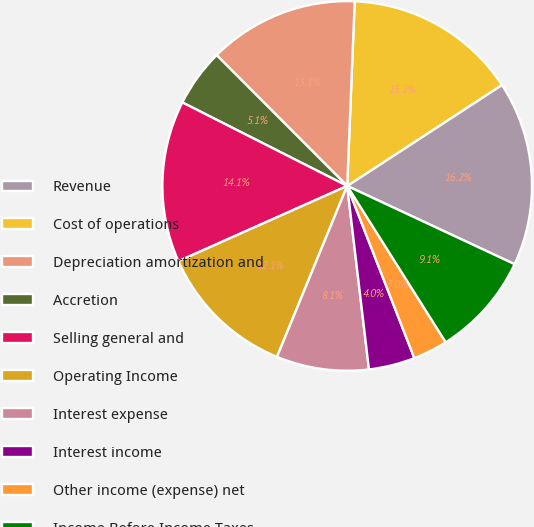Convert chart to OTSL. <chart><loc_0><loc_0><loc_500><loc_500><pie_chart><fcel>Revenue<fcel>Cost of operations<fcel>Depreciation amortization and<fcel>Accretion<fcel>Selling general and<fcel>Operating Income<fcel>Interest expense<fcel>Interest income<fcel>Other income (expense) net<fcel>Income Before Income Taxes<nl><fcel>16.16%<fcel>15.15%<fcel>13.13%<fcel>5.05%<fcel>14.14%<fcel>12.12%<fcel>8.08%<fcel>4.04%<fcel>3.03%<fcel>9.09%<nl></chart> 